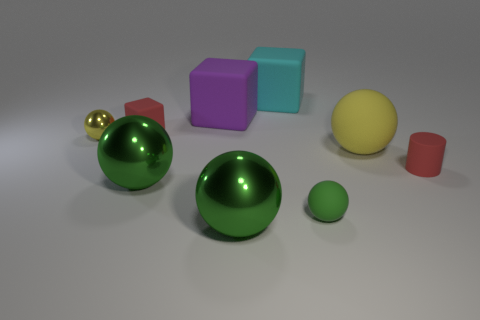Subtract all large green metal spheres. How many spheres are left? 3 Add 1 green rubber spheres. How many objects exist? 10 Subtract all yellow spheres. How many spheres are left? 3 Subtract 0 gray cubes. How many objects are left? 9 Subtract all cubes. How many objects are left? 6 Subtract all yellow blocks. Subtract all blue spheres. How many blocks are left? 3 Subtract all purple balls. How many cyan blocks are left? 1 Subtract all yellow shiny spheres. Subtract all red rubber objects. How many objects are left? 6 Add 5 cyan blocks. How many cyan blocks are left? 6 Add 3 large gray objects. How many large gray objects exist? 3 